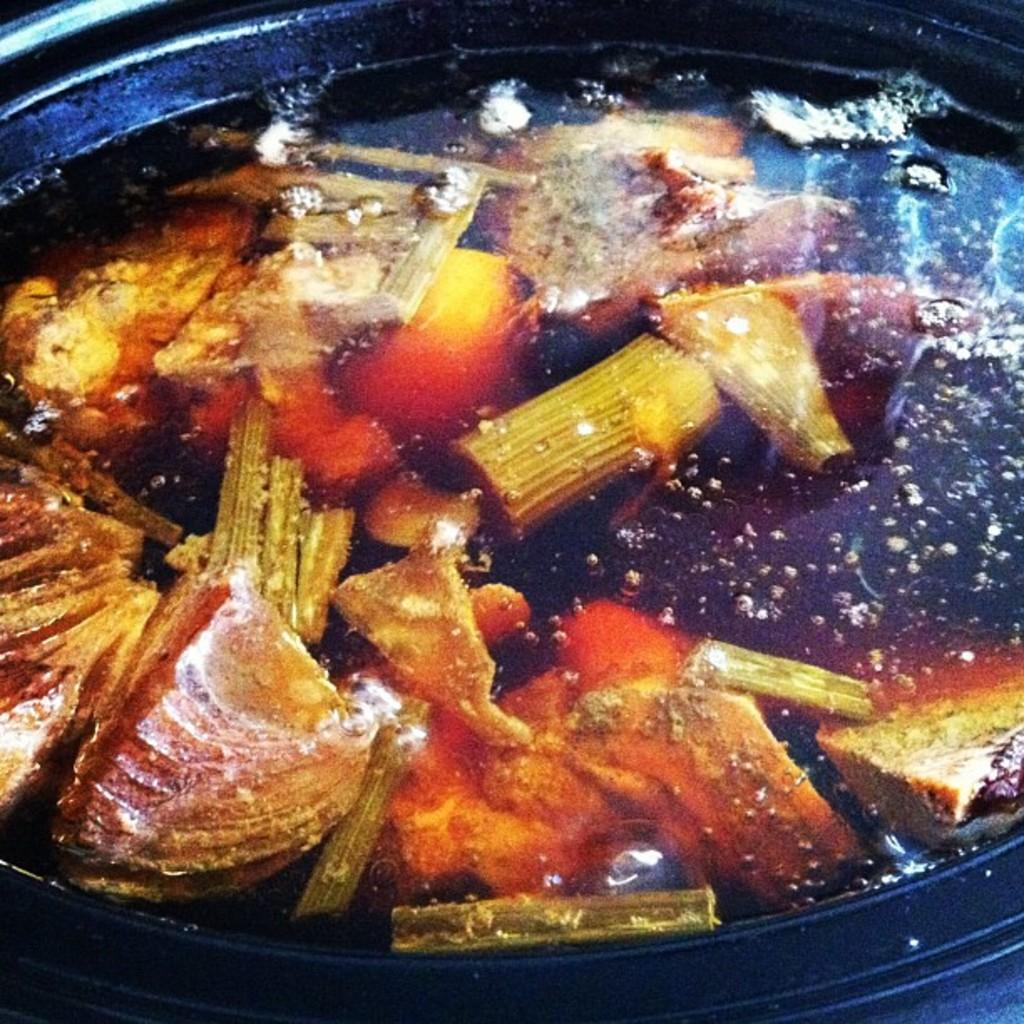What is the main subject of the image? There is a food item in the image. How is the food item being prepared or served? The food item is in an iron skillet. What type of bread can be seen on the person's chin in the image? There is no person or bread visible on a chin in the image. 